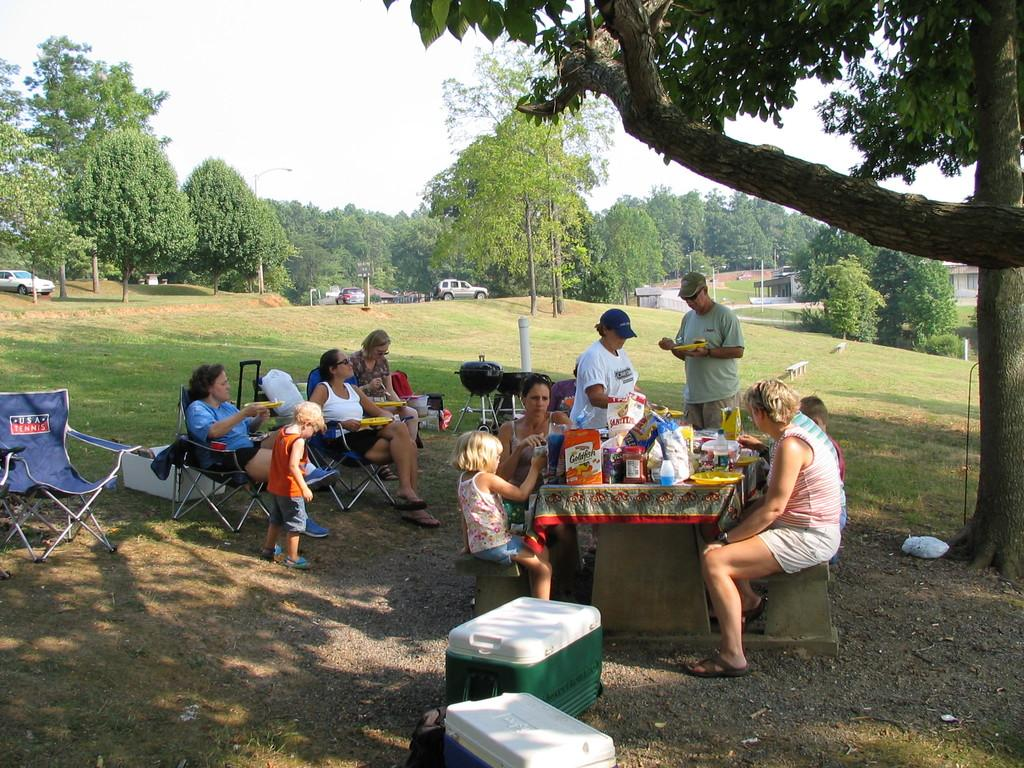What type of natural elements can be seen in the image? There are trees in the image. What type of man-made object is present in the image? There is a street light in the image. What type of transportation can be seen in the image? There are vehicles in the image. What type of living organisms can be seen in the image? There are plants in the image. What type of furniture is present in the image? There are chairs in the image. What type of human presence can be seen in the image? There are people in the image. What type of objects are on a table in the image? There are objects on a table in the image. What type of steel is used to make the protest signs in the image? There is no protest or steel present in the image; it features trees, a street light, vehicles, plants, chairs, people, and objects on a table. What shape is the steel taking in the image? There is no steel present in the image, so it is not possible to determine its shape. 